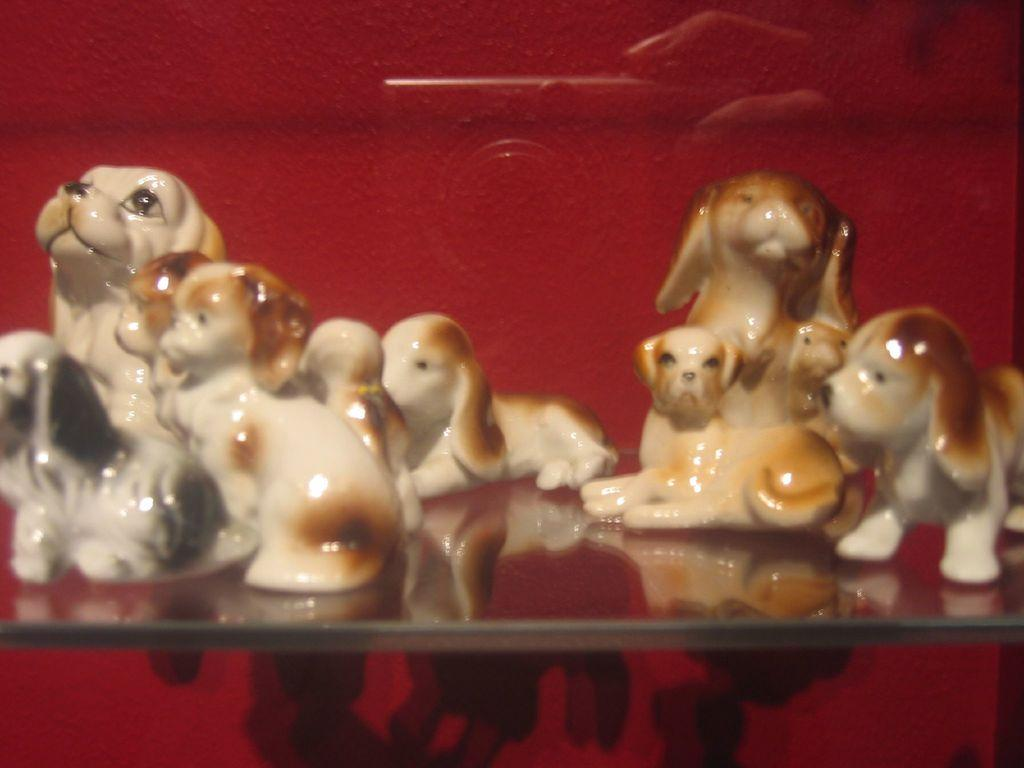What objects are present in the image? There are toys in the image. Where are the toys located? The toys are on a shelf. What can be seen in the background of the image? There is a wall visible in the background of the image. What type of bird is flying near the toys in the image? There is no bird present in the image; it only features toys on a shelf and a wall in the background. 